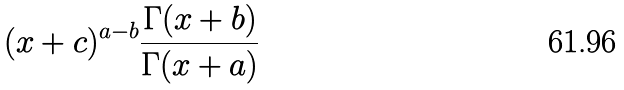Convert formula to latex. <formula><loc_0><loc_0><loc_500><loc_500>( x + c ) ^ { a - b } \frac { \Gamma ( x + b ) } { \Gamma ( x + a ) }</formula> 